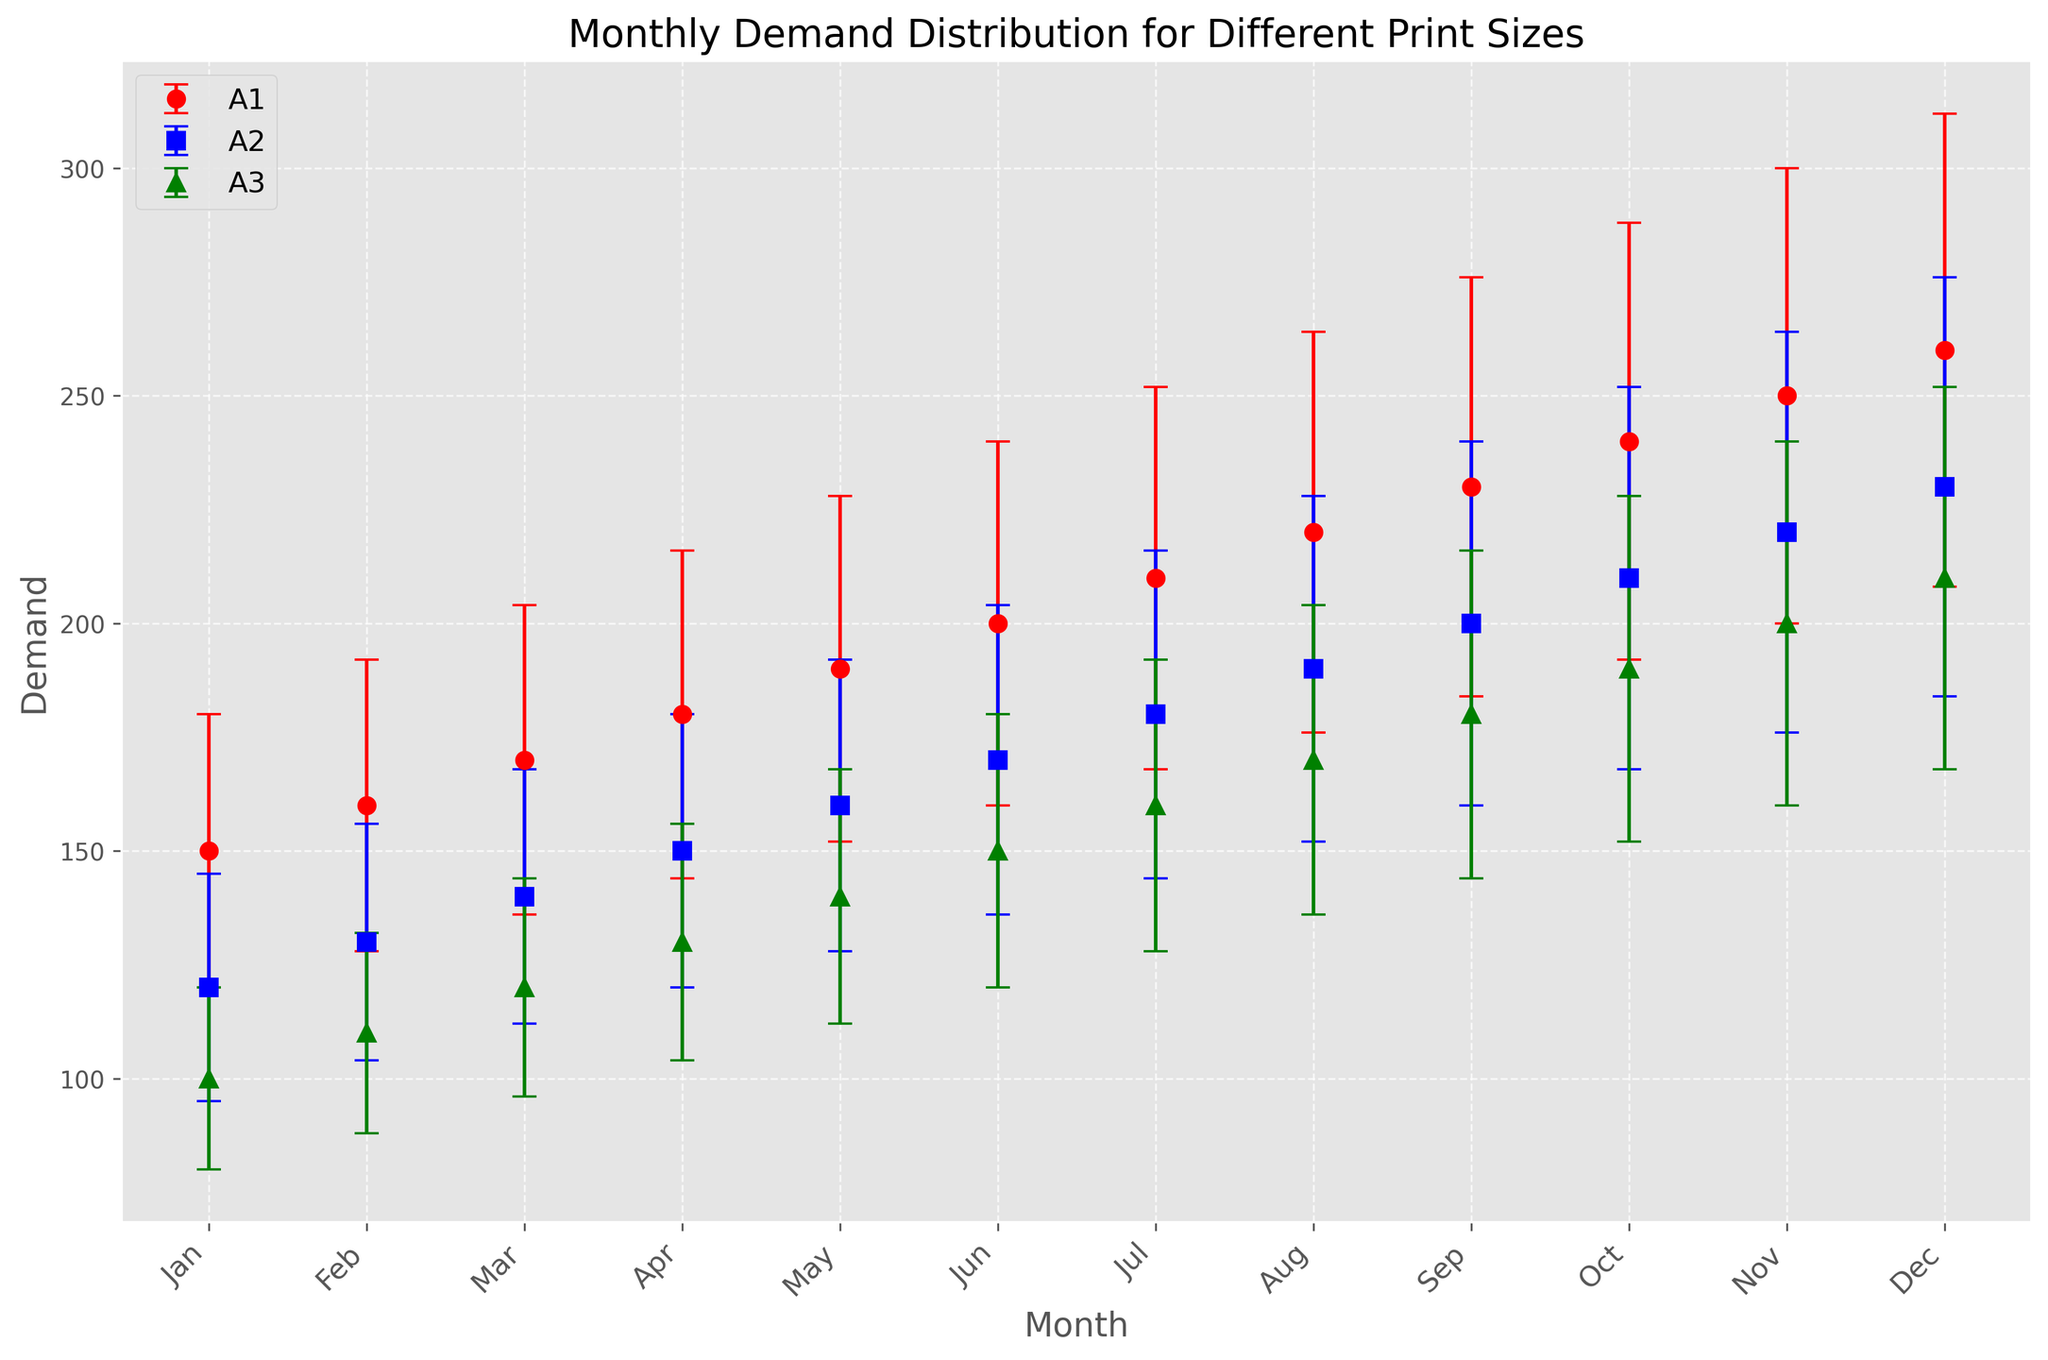Which month showed the highest average demand for A1 print size? The plot shows that December has the highest average value for A1 print size, represented by the uppermost data point on the red line.
Answer: December How does the demand for A3 print size in June compare to that in September? The plot shows the green triangle markers for A3 print size; in June, the demand is at 150, while in September it is at 180, indicating a higher demand in September.
Answer: Higher in September What is the difference in demand between A1 and A2 print sizes in October? The red marker for A1 in October is at 240, and the blue square for A2 is at 210. The difference is calculated as 240 - 210 = 30.
Answer: 30 Which print size has the smallest variability in November? Variability is indicated by the error bars. The length of the error bars for A3 (green) in November is visibly shorter than those for A1 (red) and A2 (blue), indicating the smallest variability.
Answer: A3 During which month does A2 print size have the highest variability? The highest variability for the A2 print size (blue square markers) corresponds to the longest error bar. December's error bar is the longest for A2.
Answer: December What is the average demand for all print sizes in May? Sum the means for A1, A2, and A3 in May and divide by 3. For May, A1 = 190, A2 = 160, A3 = 140. The average is (190 + 160 + 140) / 3 = 163.33.
Answer: 163.33 How did the demand for A1 print size progress from January to December? The red markers for A1 show a consistent upward trend from 150 in January to 260 in December.
Answer: Upward trend Compare the variability of A1 and A3 print sizes in February. Which one is more stable? By comparing the lengths of error bars in February, A1 (red markers) has longer bars than A3 (green markers), so A3 is more stable.
Answer: A3 What is the total demand for A2 print size across July to September? Sum the means for A2 from July to September: 180 (July) + 190 (August) + 200 (September) = 570.
Answer: 570 